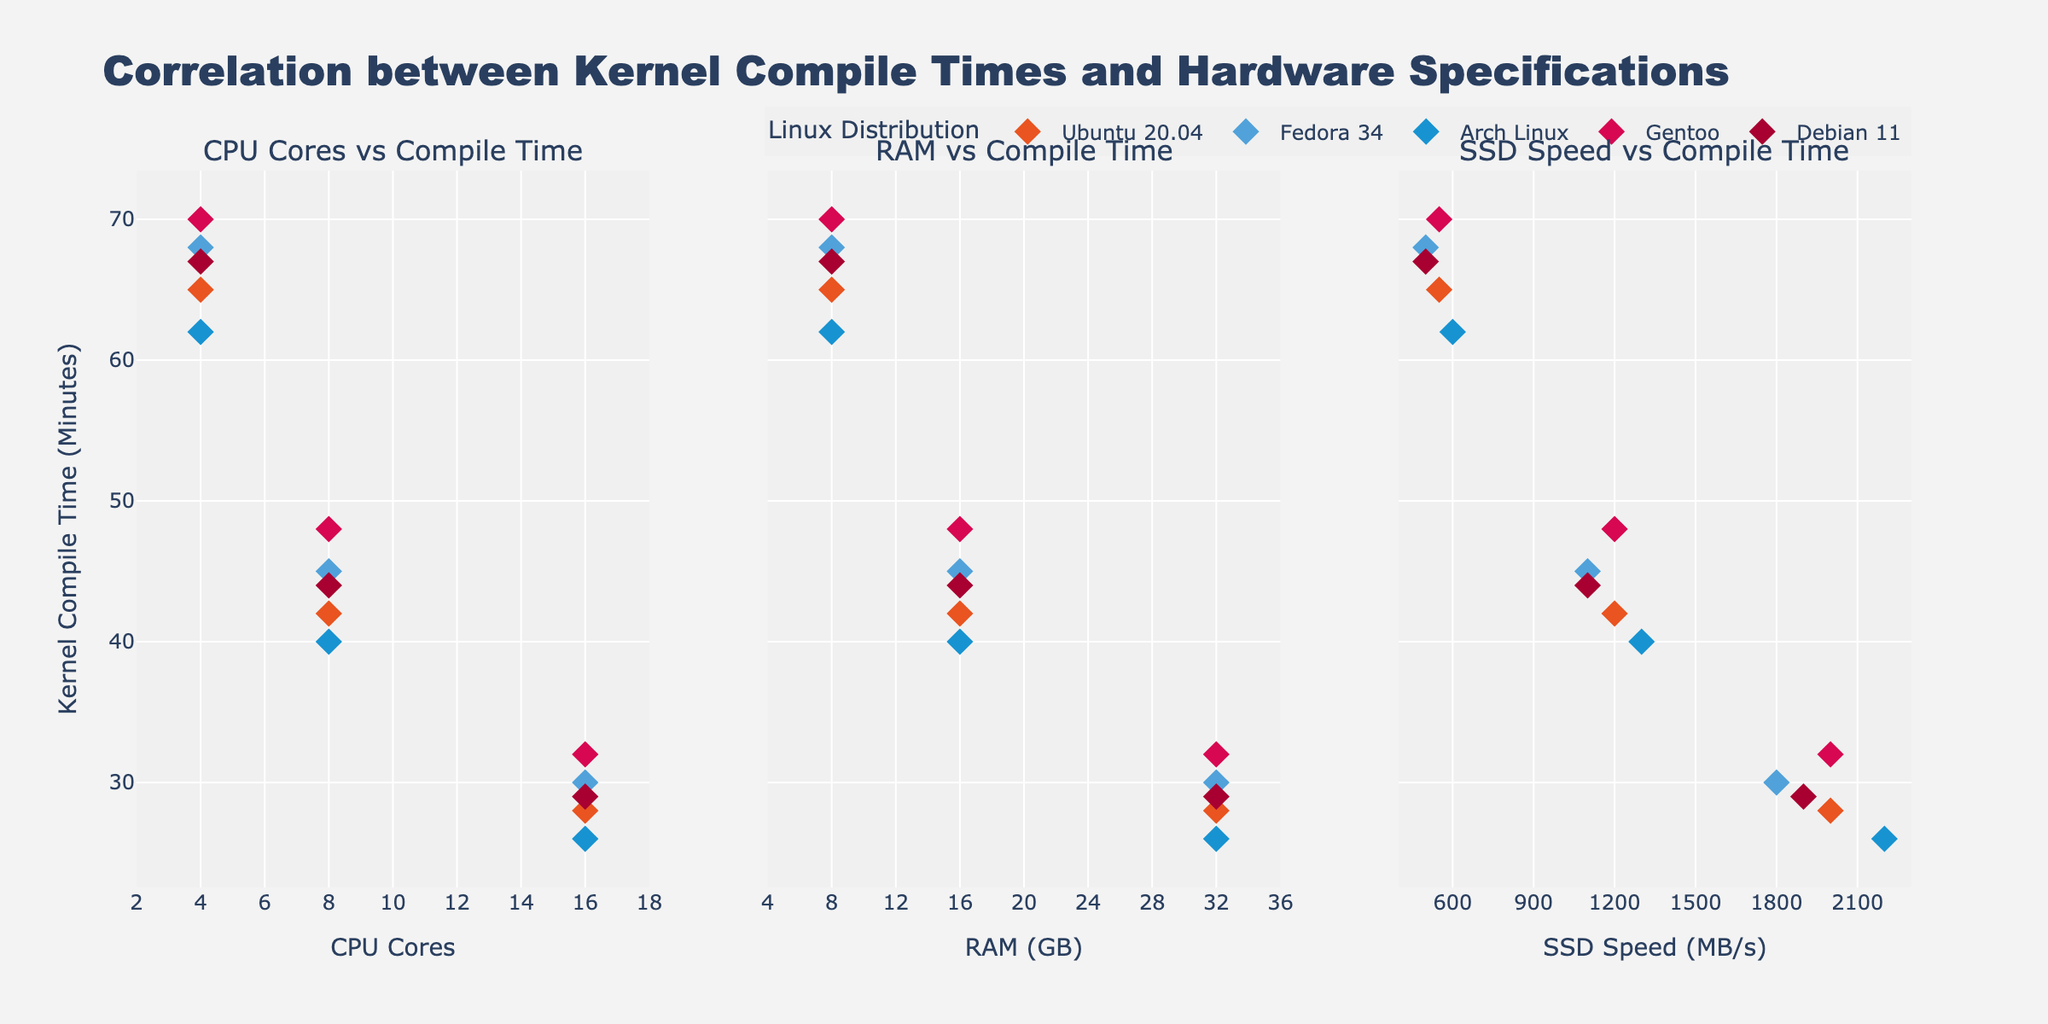What's the range of CPU cores shown in the first subplot? The x-axis of the first subplot titled "CPU Cores vs Compile Time" ranges from 2 to 18.
Answer: 2 to 18 Which distribution has the fastest compile time when using 16 CPU cores? In the first subplot ("CPU Cores vs Compile Time"), looking at the point with the highest number of CPU cores (16), the marker with the lowest y-value represents Arch Linux, which has a compile time of 26 minutes.
Answer: Arch Linux How does the increase in RAM from 8GB to 16GB affect the kernel compile time for Fedora 34? In the second subplot ("RAM vs Compile Time"), for Fedora 34 (blue markers), the compile time decreases from 68 minutes at 8GB RAM to 45 minutes at 16GB RAM, showing an improvement of 23 minutes.
Answer: Decreases by 23 minutes Which Linux distribution demonstrates the most significant overall decrease in compile time with the increase of CPU cores from 4 to 16? Comparing the points for the same distribution across all CPU cores in the first subplot, both Gentoo and Fedora 34 show a decrease, but Gentoo decreases from 70 to 32 minutes, resulting in a 38-minute reduction, which is the highest observed.
Answer: Gentoo In the third subplot, what is the relationship between SSD Speed and kernel compile time for Debian 11? Looking at the third subplot ("SSD Speed vs Compile Time") for Debian 11 (red markers), as the SSD speed increases from 500 MB/s to 1900 MB/s, the compile time decreases from 67 minutes to 29 minutes, indicating an inverse relationship.
Answer: Inverse relationship Comparing distributions, which one shows consistent compile times around the same level of RAM? Across the second subplot, `Ubuntu 20.04` consistently shows decreasing compile times with increasing RAM, without significant outliers or large fluctuations.
Answer: Ubuntu 20.04 Which subplot title corresponds to the figure comparing RAM capacity with kernel compile times? The subplot title for the y-axis representing kernel compile times and the x-axis representing RAM capacity is "RAM vs Compile Time".
Answer: RAM vs Compile Time Which distribution achieves a kernel compile time of less than 30 minutes and what hardware configurations achieve this? Reviewing all subplots for compile times below 30 minutes, only `Arch Linux` (with 16 CPU cores, 32GB RAM, and 2200 MBps SSD speed), `Gentoo` (with 16 CPU cores, 32GB RAM, and 2000 MBps SSD speed), and `Debian 11` (with 16 CPU cores, 32GB RAM, and 1900 MBps SSD speed) achieve these compile times.
Answer: Arch Linux, Gentoo, Debian 11 at high hardware configurations From the plotted data, what is the compile time range for distributions using 8 CPU cores and 16GB RAM? Referencing the first two subplots, where 8 CPU cores and 16GB RAM are utilized, compile times are: Ubuntu 20.04 (42 min), Fedora 34 (45 min), Arch Linux (40 min), Gentoo (48 min), and Debian 11 (44 min). Thus, the range is from 40 to 48 minutes.
Answer: 40 to 48 minutes How is the legend titled and oriented in the plot? The legend is labeled as 'Linux Distribution' and is oriented horizontally at the top-right of the plot, just above the subplots.
Answer: 'Linux Distribution', horizontal at the top-right 